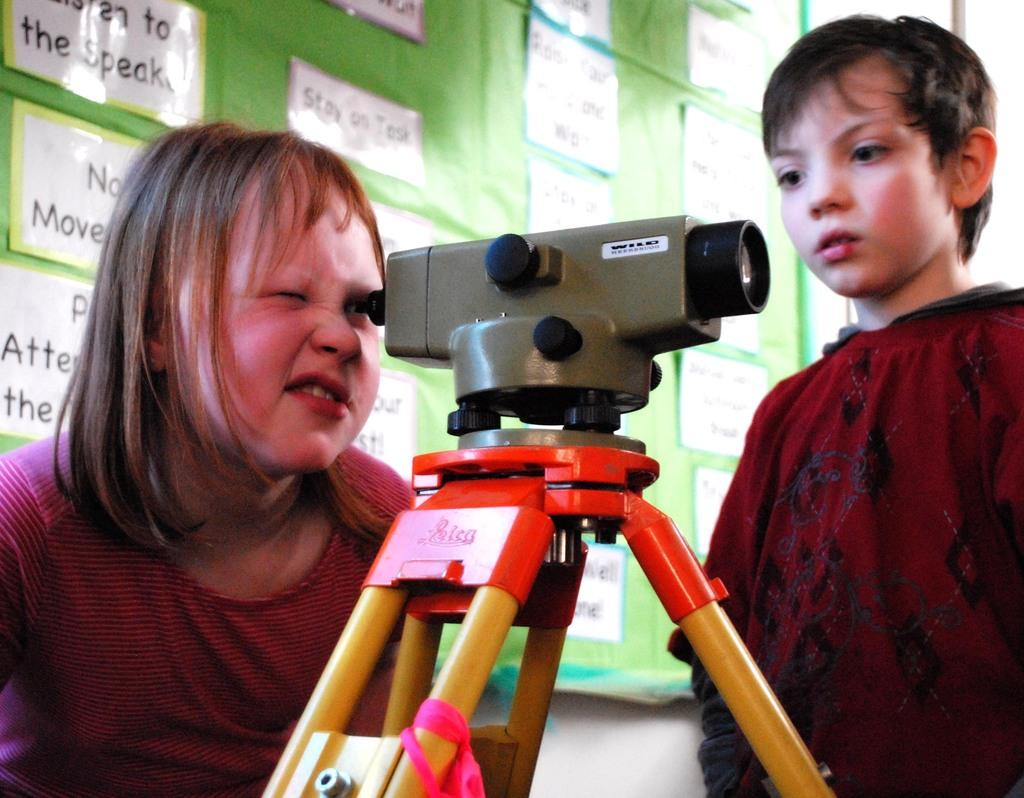How many people are present in the image? There is a boy and a girl in the image. What objects are related to photography in the image? There is a camera and a tripod in the image. What can be seen in the background of the image? There is a wall and a board with posters in the background of the image. What type of prose can be heard being read by the yak in the image? There is no yak present in the image, and therefore no prose can be heard being read. 